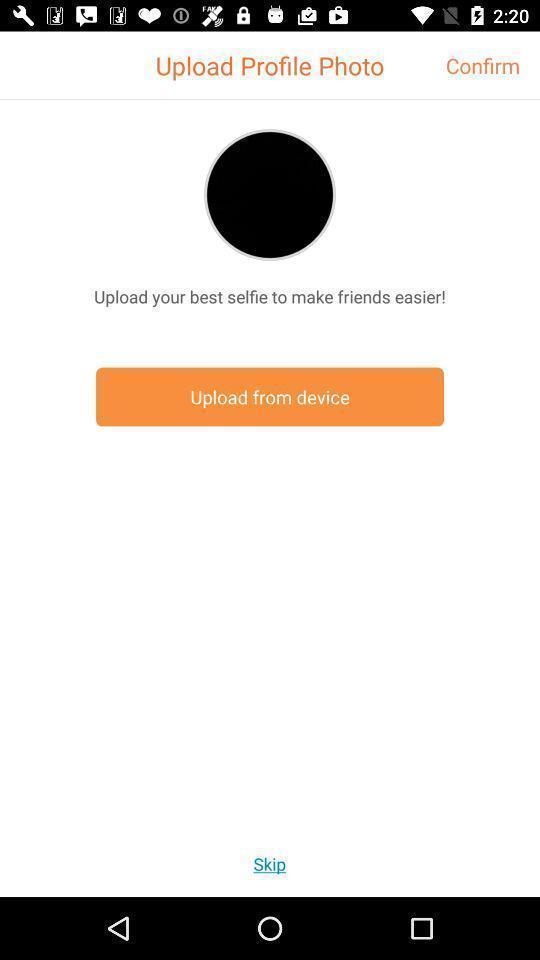Tell me what you see in this picture. Screen shows to upload a profile photo. 